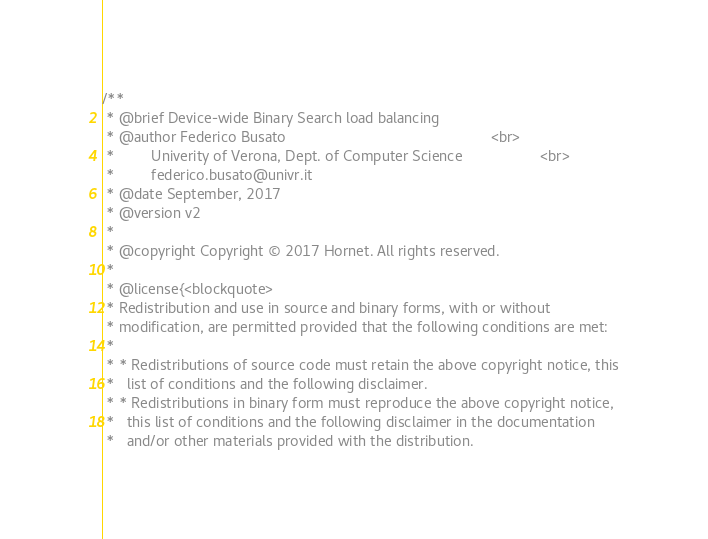Convert code to text. <code><loc_0><loc_0><loc_500><loc_500><_Cuda_>/**
 * @brief Device-wide Binary Search load balancing
 * @author Federico Busato                                                  <br>
 *         Univerity of Verona, Dept. of Computer Science                   <br>
 *         federico.busato@univr.it
 * @date September, 2017
 * @version v2
 *
 * @copyright Copyright © 2017 Hornet. All rights reserved.
 *
 * @license{<blockquote>
 * Redistribution and use in source and binary forms, with or without
 * modification, are permitted provided that the following conditions are met:
 *
 * * Redistributions of source code must retain the above copyright notice, this
 *   list of conditions and the following disclaimer.
 * * Redistributions in binary form must reproduce the above copyright notice,
 *   this list of conditions and the following disclaimer in the documentation
 *   and/or other materials provided with the distribution.</code> 